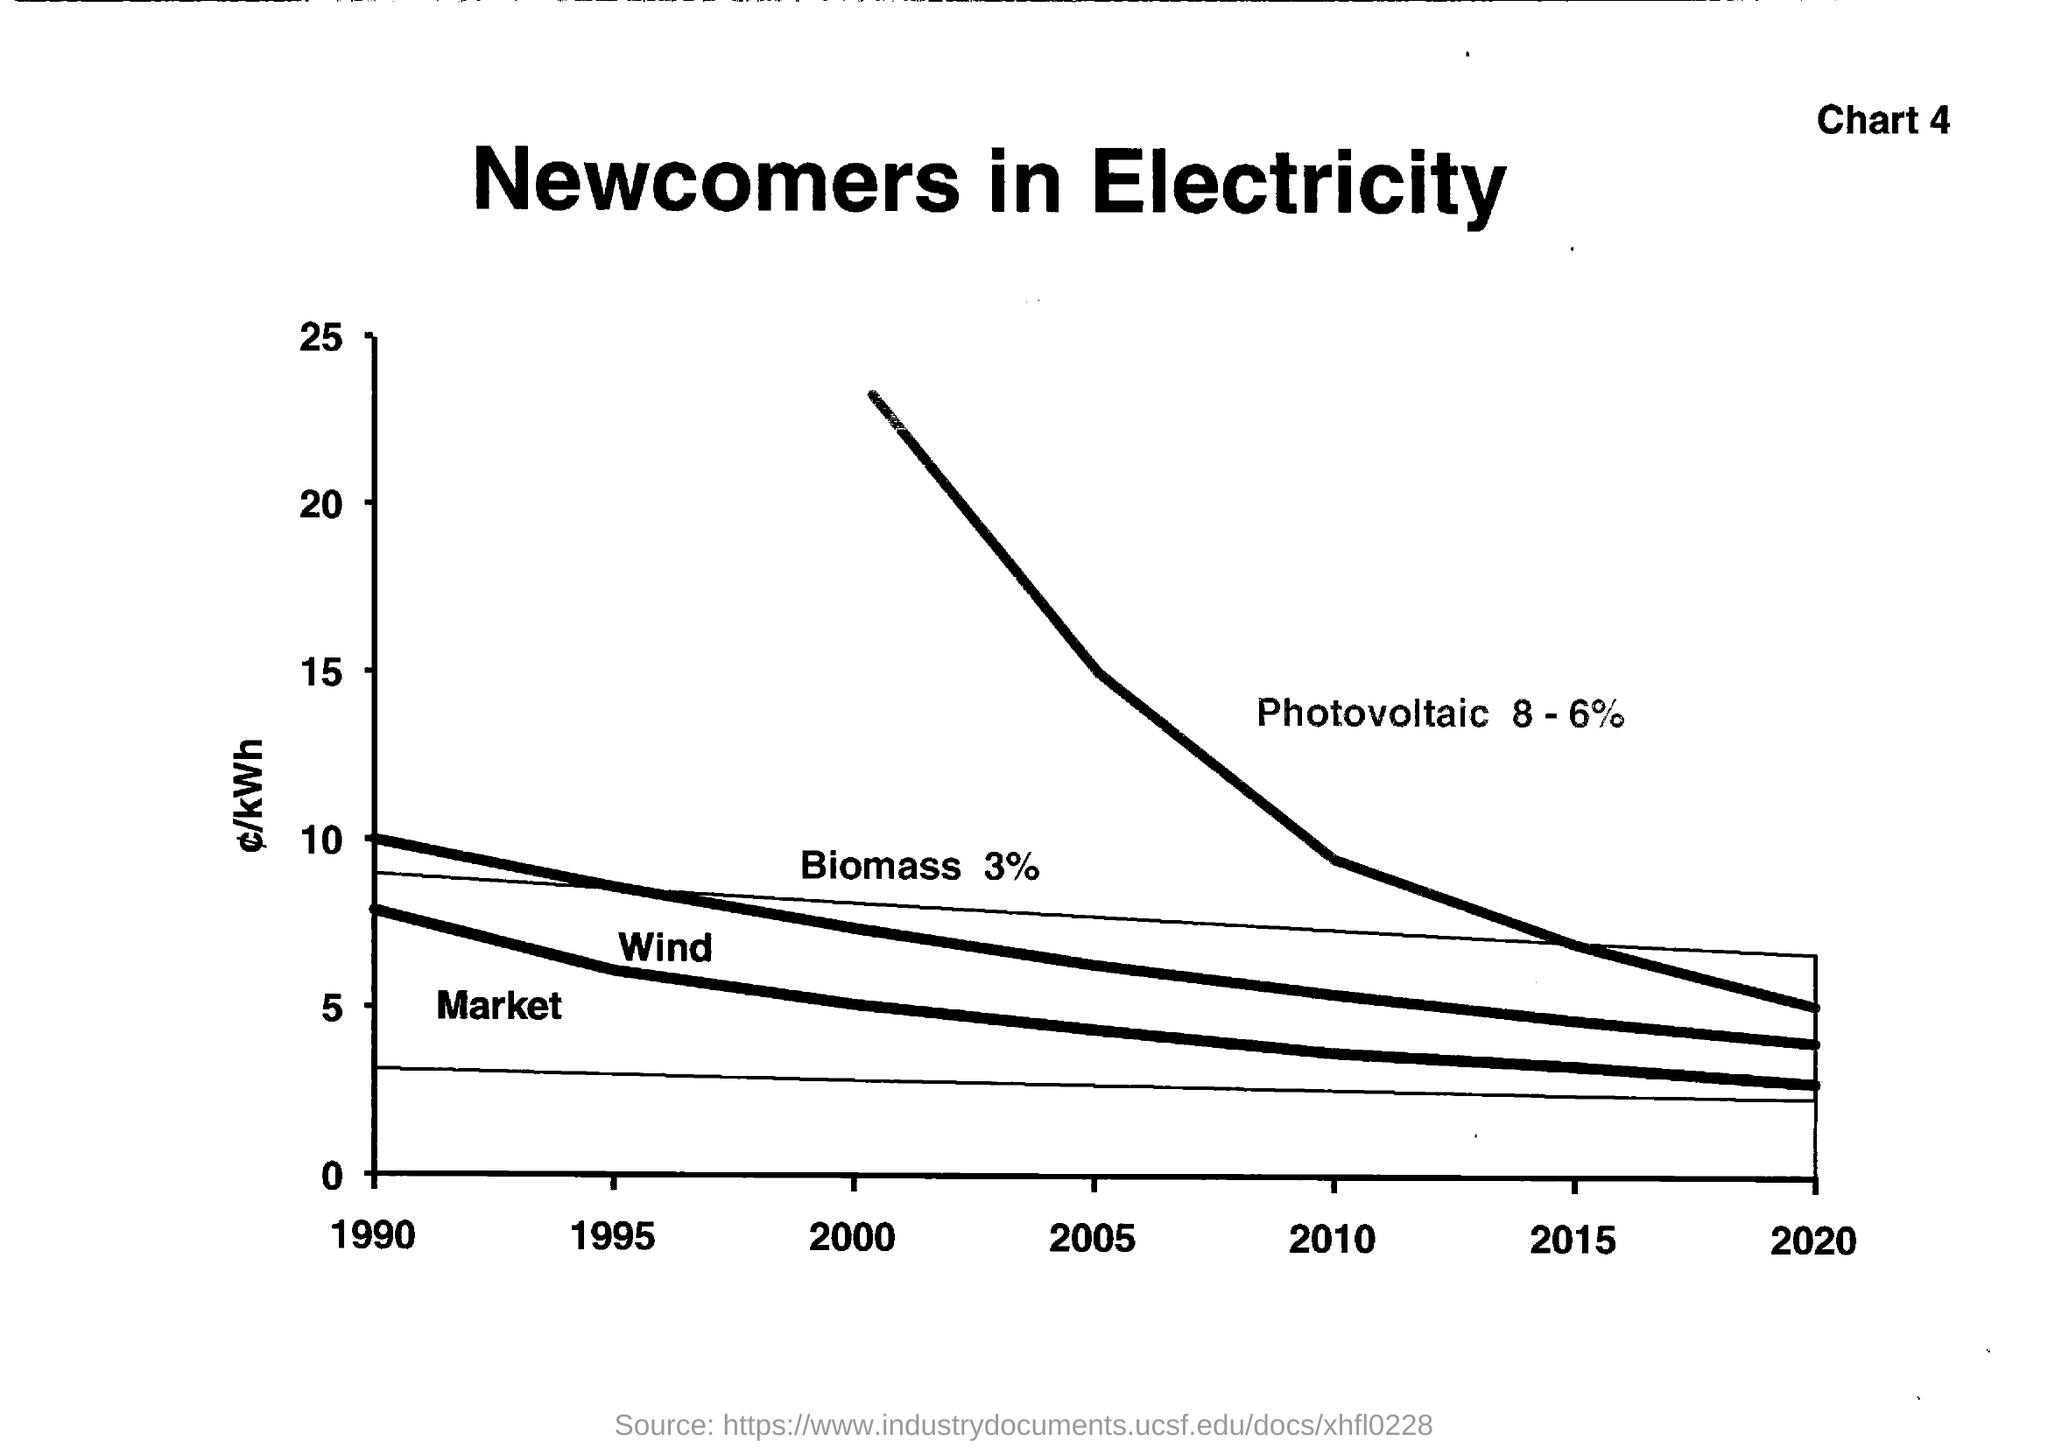What is the Title of the document ?
Keep it short and to the point. Newcomers in Electricity. What is the Chart Number ?
Your answer should be very brief. 4. What is the Photovoltaic Percentage ?
Ensure brevity in your answer.  8 - 6%. What is the Biomass Percentage ?
Your answer should be very brief. 3%. 